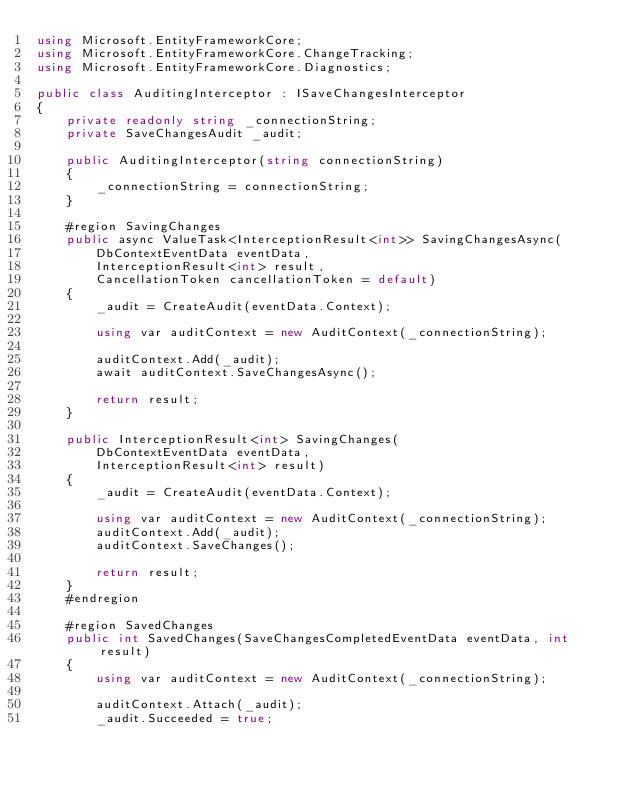<code> <loc_0><loc_0><loc_500><loc_500><_C#_>using Microsoft.EntityFrameworkCore;
using Microsoft.EntityFrameworkCore.ChangeTracking;
using Microsoft.EntityFrameworkCore.Diagnostics;

public class AuditingInterceptor : ISaveChangesInterceptor
{
    private readonly string _connectionString;
    private SaveChangesAudit _audit;

    public AuditingInterceptor(string connectionString)
    {
        _connectionString = connectionString;
    }

    #region SavingChanges
    public async ValueTask<InterceptionResult<int>> SavingChangesAsync(
        DbContextEventData eventData,
        InterceptionResult<int> result,
        CancellationToken cancellationToken = default)
    {
        _audit = CreateAudit(eventData.Context);

        using var auditContext = new AuditContext(_connectionString);

        auditContext.Add(_audit);
        await auditContext.SaveChangesAsync();

        return result;
    }

    public InterceptionResult<int> SavingChanges(
        DbContextEventData eventData,
        InterceptionResult<int> result)
    {
        _audit = CreateAudit(eventData.Context);

        using var auditContext = new AuditContext(_connectionString);
        auditContext.Add(_audit);
        auditContext.SaveChanges();

        return result;
    }
    #endregion

    #region SavedChanges
    public int SavedChanges(SaveChangesCompletedEventData eventData, int result)
    {
        using var auditContext = new AuditContext(_connectionString);

        auditContext.Attach(_audit);
        _audit.Succeeded = true;</code> 